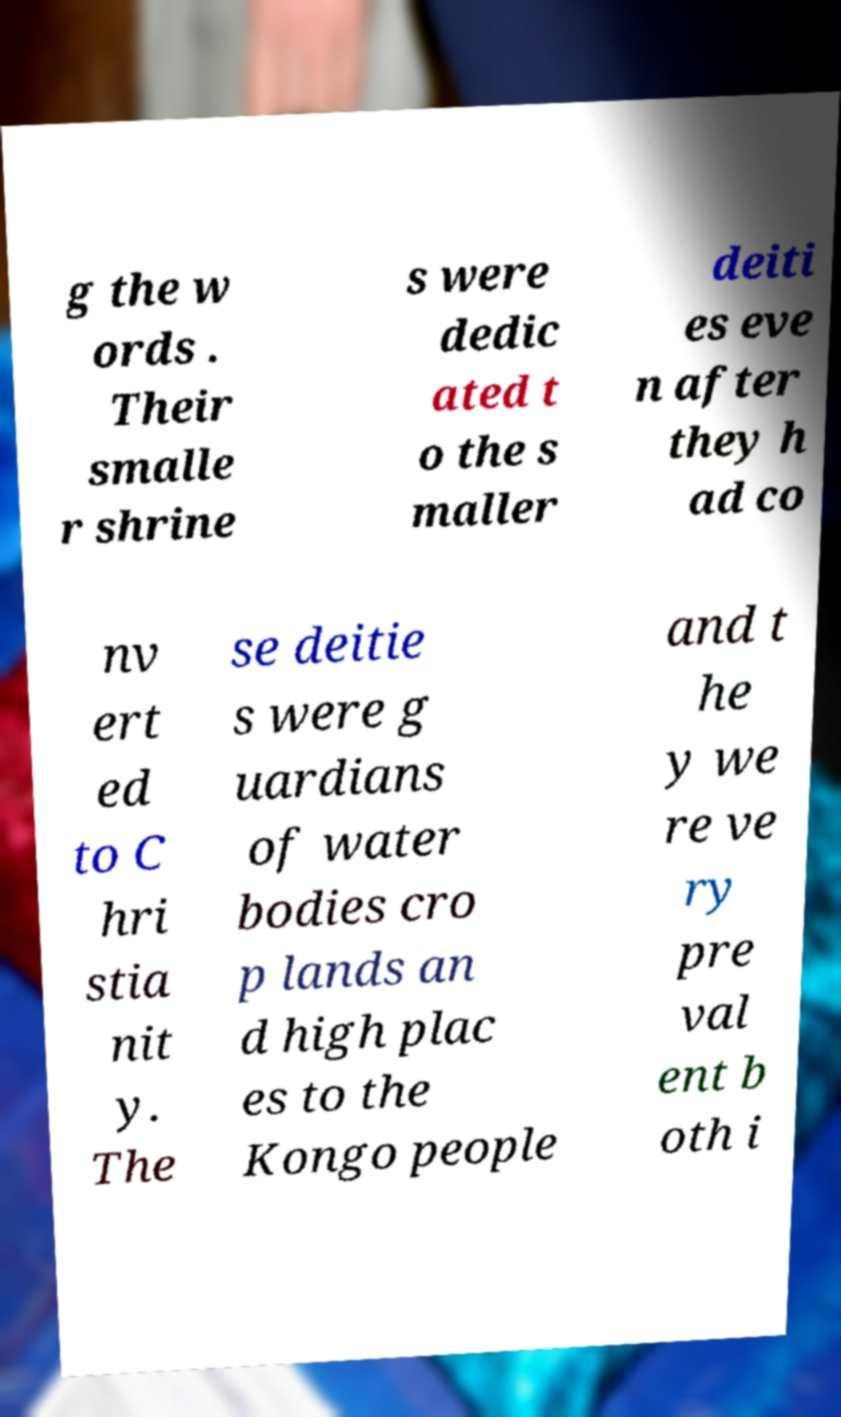Could you extract and type out the text from this image? g the w ords . Their smalle r shrine s were dedic ated t o the s maller deiti es eve n after they h ad co nv ert ed to C hri stia nit y. The se deitie s were g uardians of water bodies cro p lands an d high plac es to the Kongo people and t he y we re ve ry pre val ent b oth i 